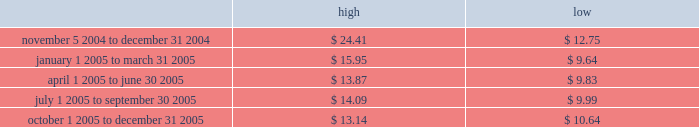Part ii price range our common stock commenced trading on the nasdaq national market under the symbol 201cmktx 201d on november 5 , 2004 .
Prior to that date , there was no public market for our common stock .
The high and low bid information for our common stock , as reported by nasdaq , was as follows : on march 8 , 2006 , the last reported closing price of our common stock on the nasdaq national market was $ 12.59 .
Holders there were approximately 114 holders of record of our common stock as of march 8 , 2006 .
Dividend policy we have not declared or paid any cash dividends on our capital stock since our inception .
We intend to retain future earnings to finance the operation and expansion of our business and do not anticipate paying any cash dividends in the foreseeable future .
In the event we decide to declare dividends on our common stock in the future , such declaration will be subject to the discretion of our board of directors .
Our board may take into account such matters as general business conditions , our financial results , capital requirements , contractual , legal , and regulatory restrictions on the payment of dividends by us to our stockholders or by our subsidiaries to us and any such other factors as our board may deem relevant .
Use of proceeds on november 4 , 2004 , the registration statement relating to our initial public offering ( no .
333-112718 ) was declared effective .
We received net proceeds from the sale of the shares of our common stock in the offering of $ 53.9 million , at an initial public offering price of $ 11.00 per share , after deducting underwriting discounts and commissions and estimated offering expenses .
Except for salaries , and reimbursements for travel expenses and other out-of -pocket costs incurred in the ordinary course of business , none of the proceeds from the offering have been paid by us , directly or indirectly , to any of our directors or officers or any of their associates , or to any persons owning ten percent or more of our outstanding stock or to any of our affiliates .
We have invested the proceeds from the offering in cash and cash equivalents and short-term marketable securities .
Item 5 .
Market for registrant 2019s common equity , related stockholder matters and issuer purchases of equity securities .

What was the highest share price in the period october 1 2005 to december 31 2005? 
Computations: table_max(october 1 2005 to december 31 2005, none)
Answer: 13.14. 